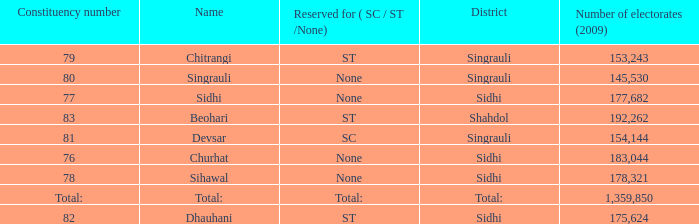What is Beohari's highest number of electorates? 192262.0. 